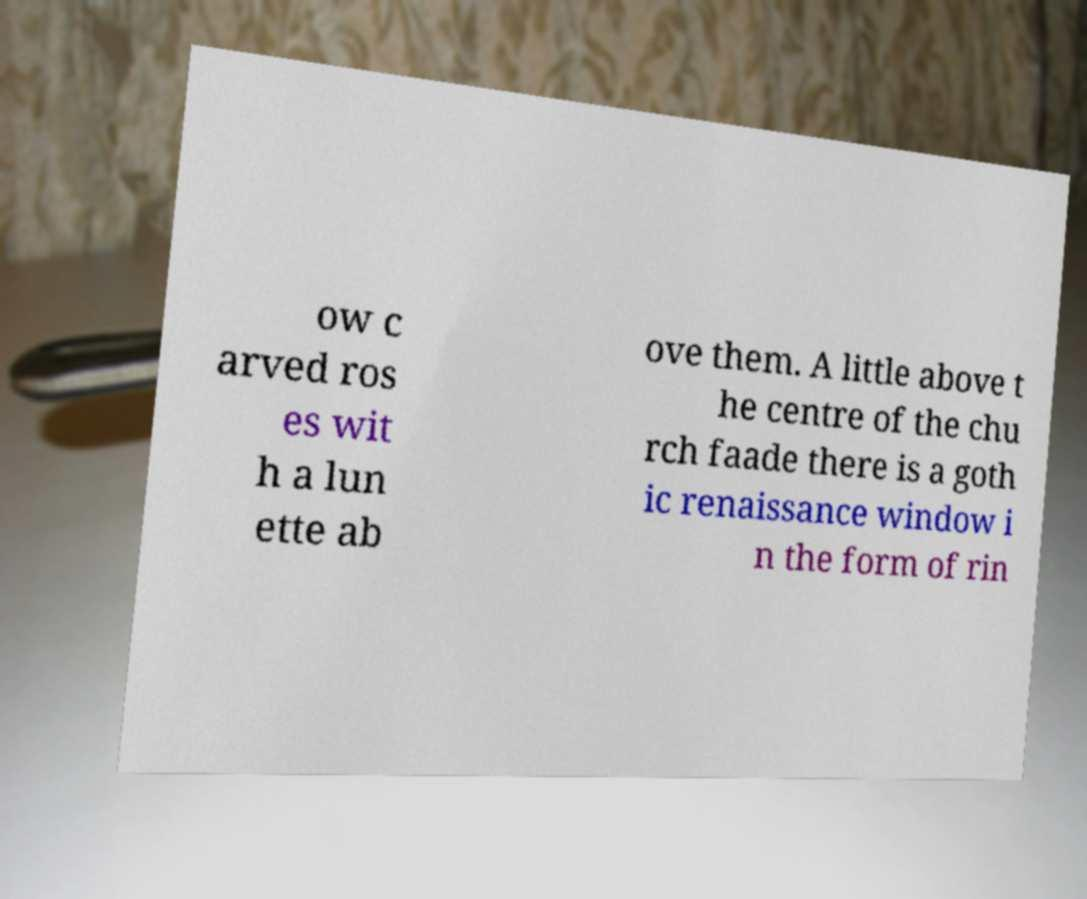Could you assist in decoding the text presented in this image and type it out clearly? ow c arved ros es wit h a lun ette ab ove them. A little above t he centre of the chu rch faade there is a goth ic renaissance window i n the form of rin 